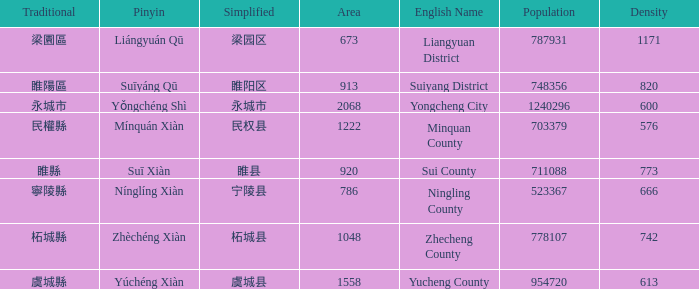How many figures are there for density for Yucheng County? 1.0. 